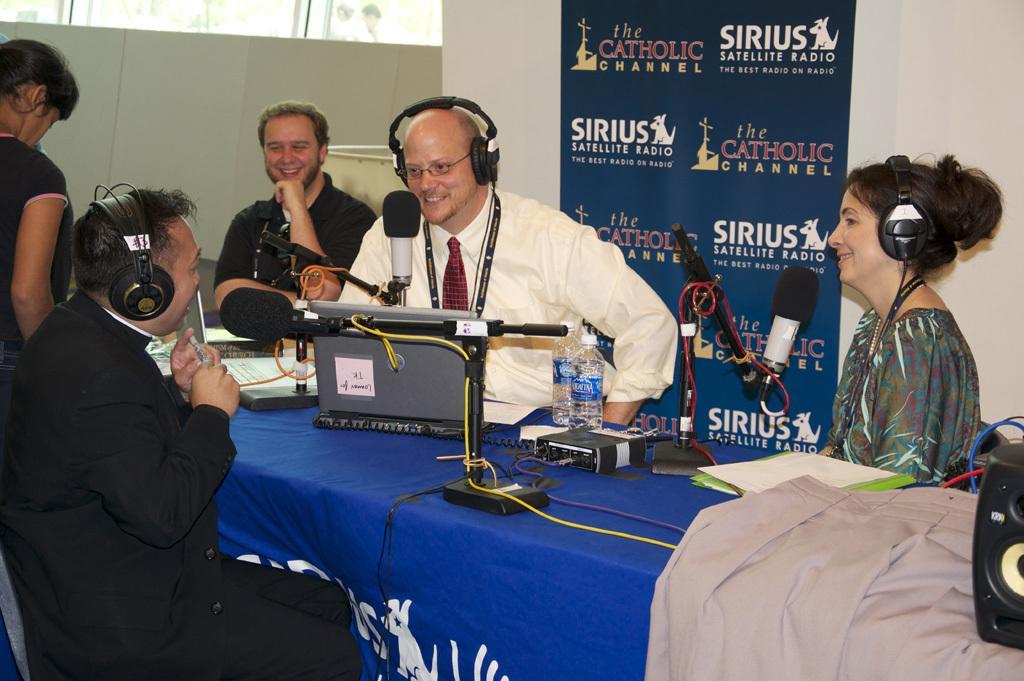Can you describe this image briefly? In this picture we can see some people sitting in front of a table, these three persons wore headphones, we can see a laptop, two water bottle, a cloth and papers present on the table, we can see microphones here, in the background there is a wall, we can see a speaker here. 